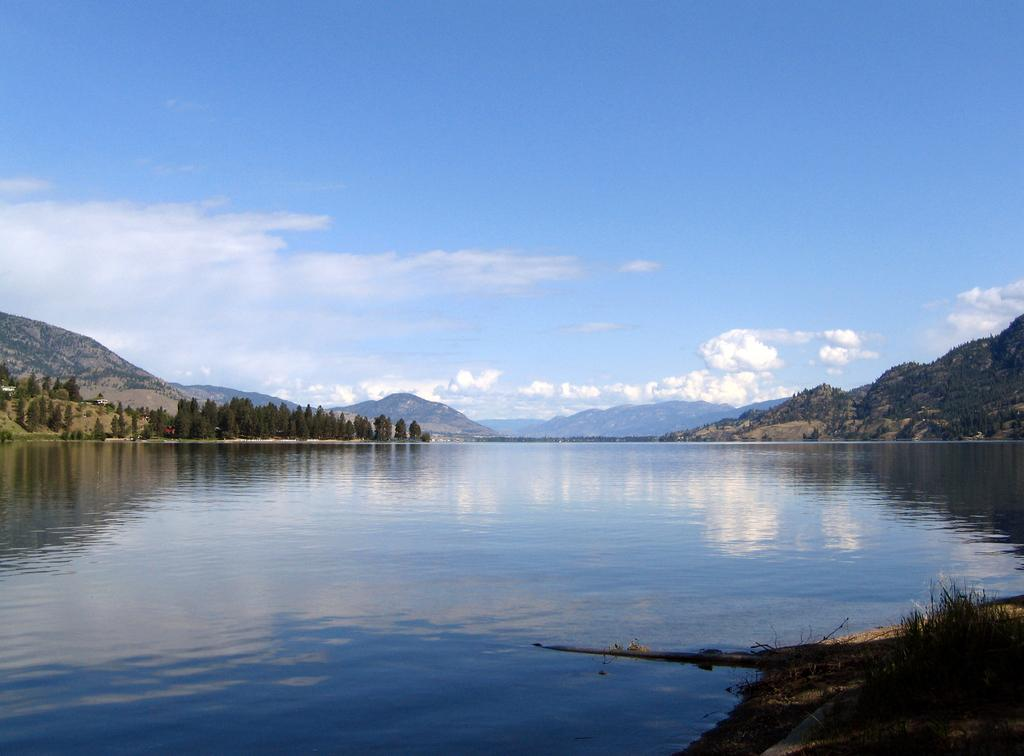What type of body of water is in the image? There is a lake in the image. What can be seen behind the lake? There are hills and trees behind the lake. What is visible in the sky in the image? The sky is visible in the image, and clouds are present. What type of card is floating on the lake in the image? There is: There is no card present in the image; it features a lake with hills and trees behind it. 